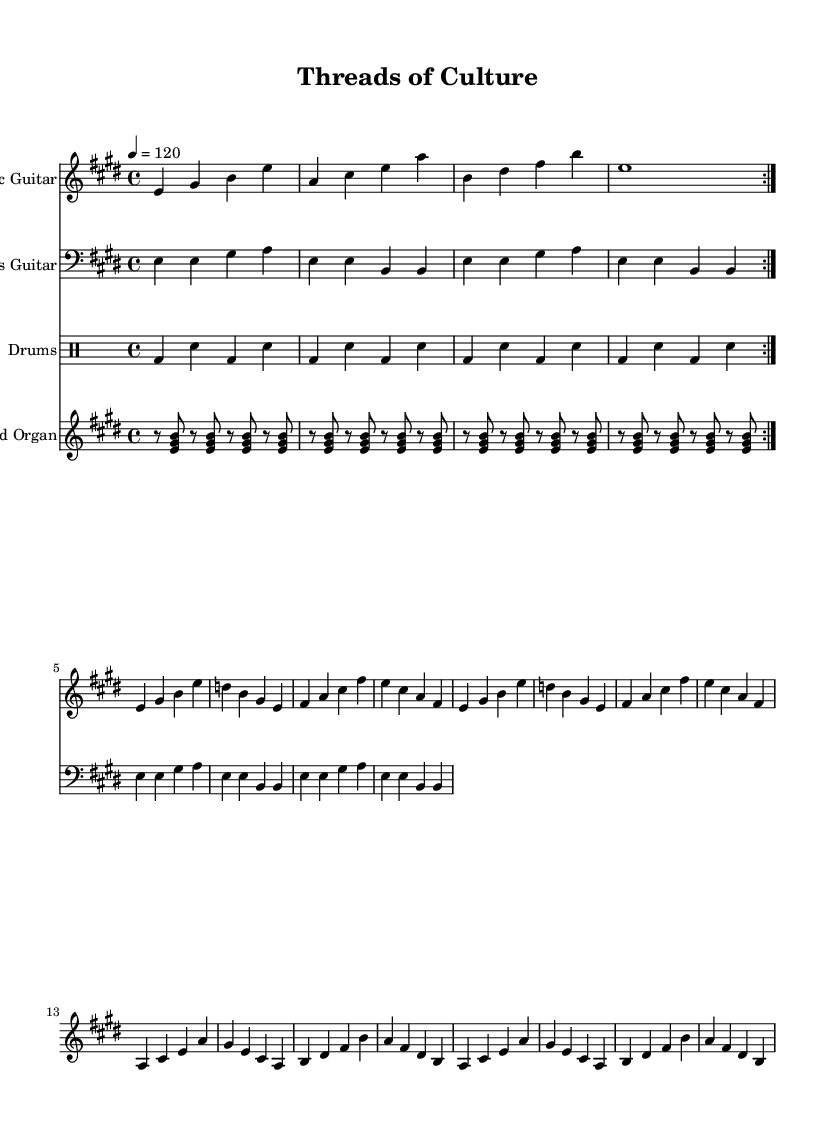What is the key signature of this music? The key signature is E major, which consists of four sharps (F#, C#, G#, D#). You can identify the key signature by looking at the sharp symbols placed at the beginning of the staff in the sheet music, indicating that the piece is in E major.
Answer: E major What is the time signature of the piece? The time signature is 4/4, which means there are four beats in each measure and the quarter note gets one beat. This is clearly marked at the beginning of the music and is a common time signature in many musical genres, including blues.
Answer: 4/4 What is the tempo marking for the music? The tempo marking is 120 beats per minute. This is indicated at the beginning of the score and helps musicians understand the intended speed for performance.
Answer: 120 How many repetitions of the intro section are indicated? The intro section is indicated to be repeated two times, as shown by the repeat volta markings in the sheet music (the symbols that show the section should be played multiple times).
Answer: 2 What instruments are featured in the score? The score features an electric guitar, bass guitar, drums, and Hammond organ. Each instrument is clearly labeled at the beginning of its respective staff, making it easy to identify the instruments involved in the composition.
Answer: Electric Guitar, Bass Guitar, Drums, Hammond Organ How many measures are included in the electric guitar chorus? The electric guitar chorus consists of four measures. You can count the number of vertical lines separating the sections in the guitar part, which indicates the ends of measures; this shows that there are four measures in this specific section.
Answer: 4 Which musical style is represented by this piece? The musical style represented by this piece is electric blues, characterized by its distinct sound due to the electric guitar, rhythmic bass line, and lively tempo. The inclusion of specific chords and rhythmic patterns typical of blues further confirms its style.
Answer: Electric Blues 